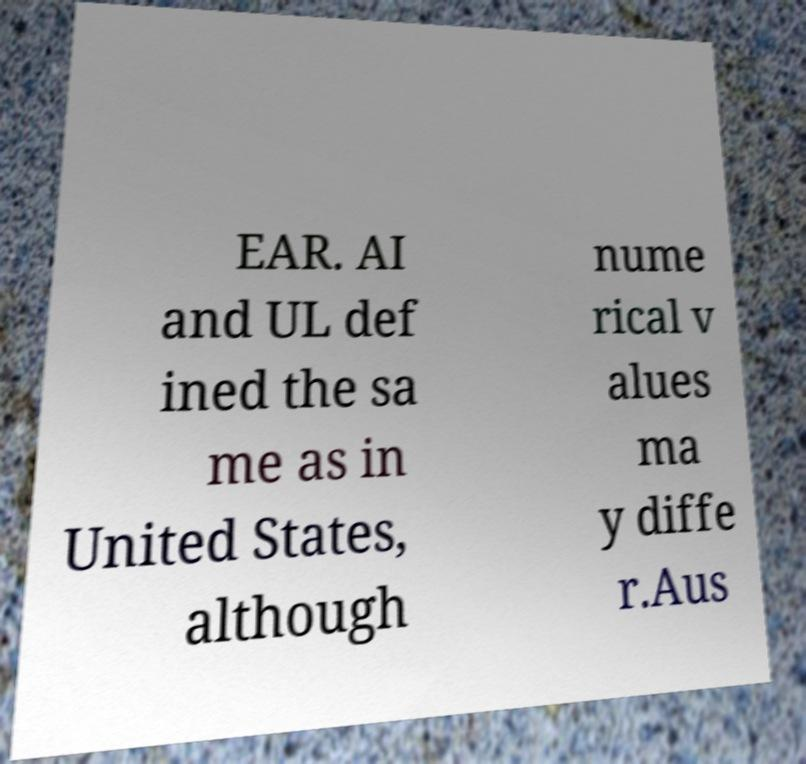For documentation purposes, I need the text within this image transcribed. Could you provide that? EAR. AI and UL def ined the sa me as in United States, although nume rical v alues ma y diffe r.Aus 